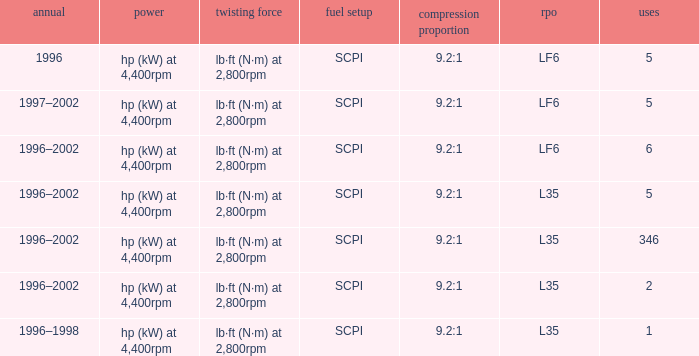What are the torque characteristics of the model with 346 applications? Lb·ft (n·m) at 2,800rpm. Can you parse all the data within this table? {'header': ['annual', 'power', 'twisting force', 'fuel setup', 'compression proportion', 'rpo', 'uses'], 'rows': [['1996', 'hp (kW) at 4,400rpm', 'lb·ft (N·m) at 2,800rpm', 'SCPI', '9.2:1', 'LF6', '5'], ['1997–2002', 'hp (kW) at 4,400rpm', 'lb·ft (N·m) at 2,800rpm', 'SCPI', '9.2:1', 'LF6', '5'], ['1996–2002', 'hp (kW) at 4,400rpm', 'lb·ft (N·m) at 2,800rpm', 'SCPI', '9.2:1', 'LF6', '6'], ['1996–2002', 'hp (kW) at 4,400rpm', 'lb·ft (N·m) at 2,800rpm', 'SCPI', '9.2:1', 'L35', '5'], ['1996–2002', 'hp (kW) at 4,400rpm', 'lb·ft (N·m) at 2,800rpm', 'SCPI', '9.2:1', 'L35', '346'], ['1996–2002', 'hp (kW) at 4,400rpm', 'lb·ft (N·m) at 2,800rpm', 'SCPI', '9.2:1', 'L35', '2'], ['1996–1998', 'hp (kW) at 4,400rpm', 'lb·ft (N·m) at 2,800rpm', 'SCPI', '9.2:1', 'L35', '1']]} 